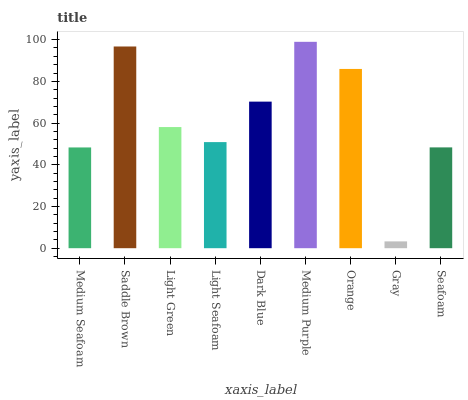Is Gray the minimum?
Answer yes or no. Yes. Is Medium Purple the maximum?
Answer yes or no. Yes. Is Saddle Brown the minimum?
Answer yes or no. No. Is Saddle Brown the maximum?
Answer yes or no. No. Is Saddle Brown greater than Medium Seafoam?
Answer yes or no. Yes. Is Medium Seafoam less than Saddle Brown?
Answer yes or no. Yes. Is Medium Seafoam greater than Saddle Brown?
Answer yes or no. No. Is Saddle Brown less than Medium Seafoam?
Answer yes or no. No. Is Light Green the high median?
Answer yes or no. Yes. Is Light Green the low median?
Answer yes or no. Yes. Is Gray the high median?
Answer yes or no. No. Is Seafoam the low median?
Answer yes or no. No. 